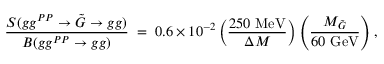<formula> <loc_0><loc_0><loc_500><loc_500>\frac { S ( g g ^ { P P } \rightarrow \tilde { G } \rightarrow g g ) } { B ( g g ^ { P P } \rightarrow g g ) } \, = \, 0 . 6 \times 1 0 ^ { - 2 } \left ( \frac { 2 5 0 M e V } { \Delta M } \right ) \left ( \frac { M _ { \tilde { G } } } { 6 0 G e V } \right ) ,</formula> 